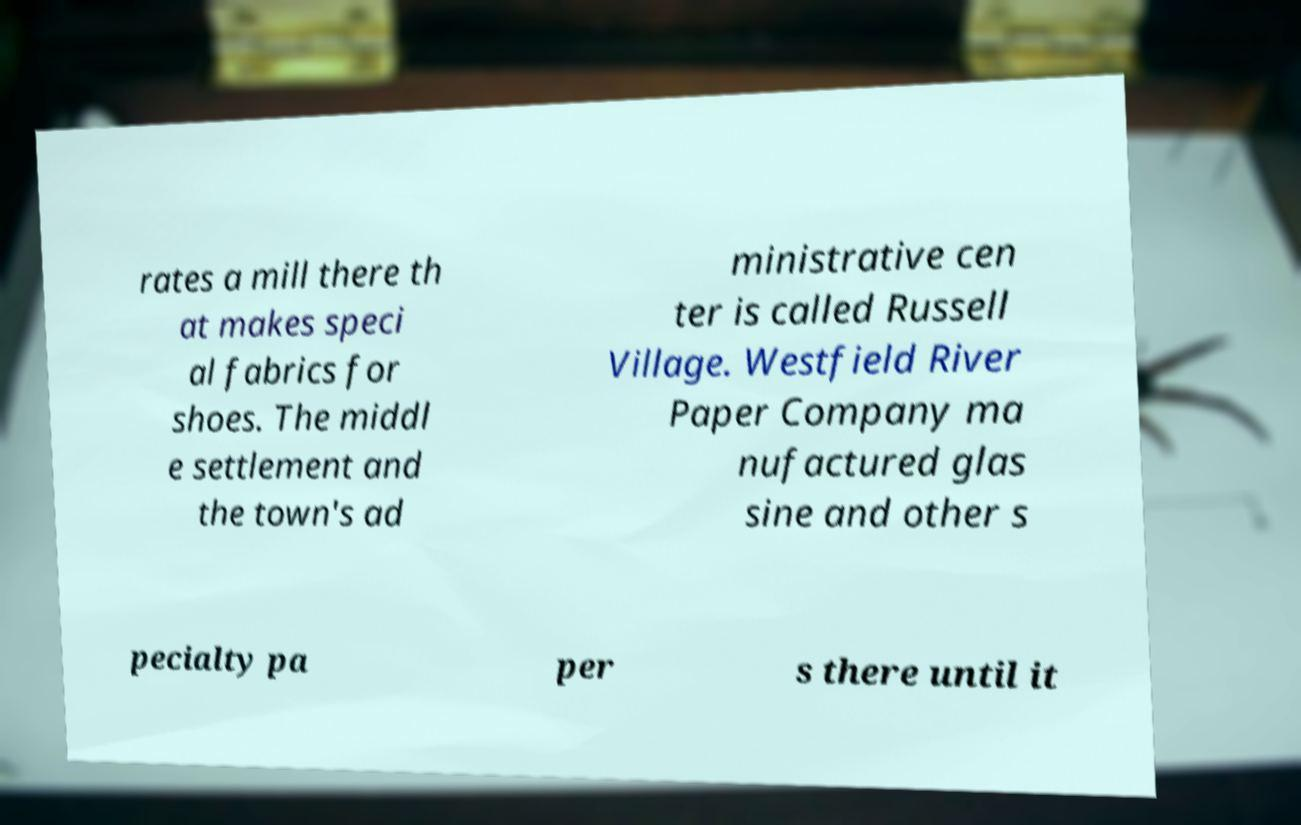What messages or text are displayed in this image? I need them in a readable, typed format. rates a mill there th at makes speci al fabrics for shoes. The middl e settlement and the town's ad ministrative cen ter is called Russell Village. Westfield River Paper Company ma nufactured glas sine and other s pecialty pa per s there until it 